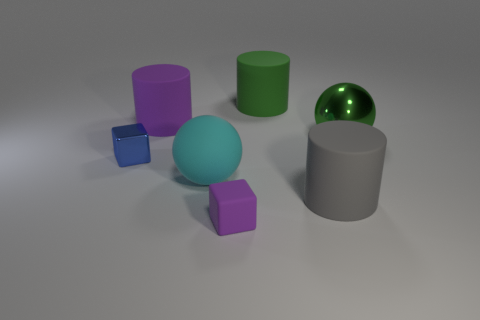Add 1 yellow cubes. How many objects exist? 8 Subtract all balls. How many objects are left? 5 Add 6 purple objects. How many purple objects exist? 8 Subtract 1 purple cylinders. How many objects are left? 6 Subtract all large cyan metal cubes. Subtract all small purple rubber cubes. How many objects are left? 6 Add 5 big green matte cylinders. How many big green matte cylinders are left? 6 